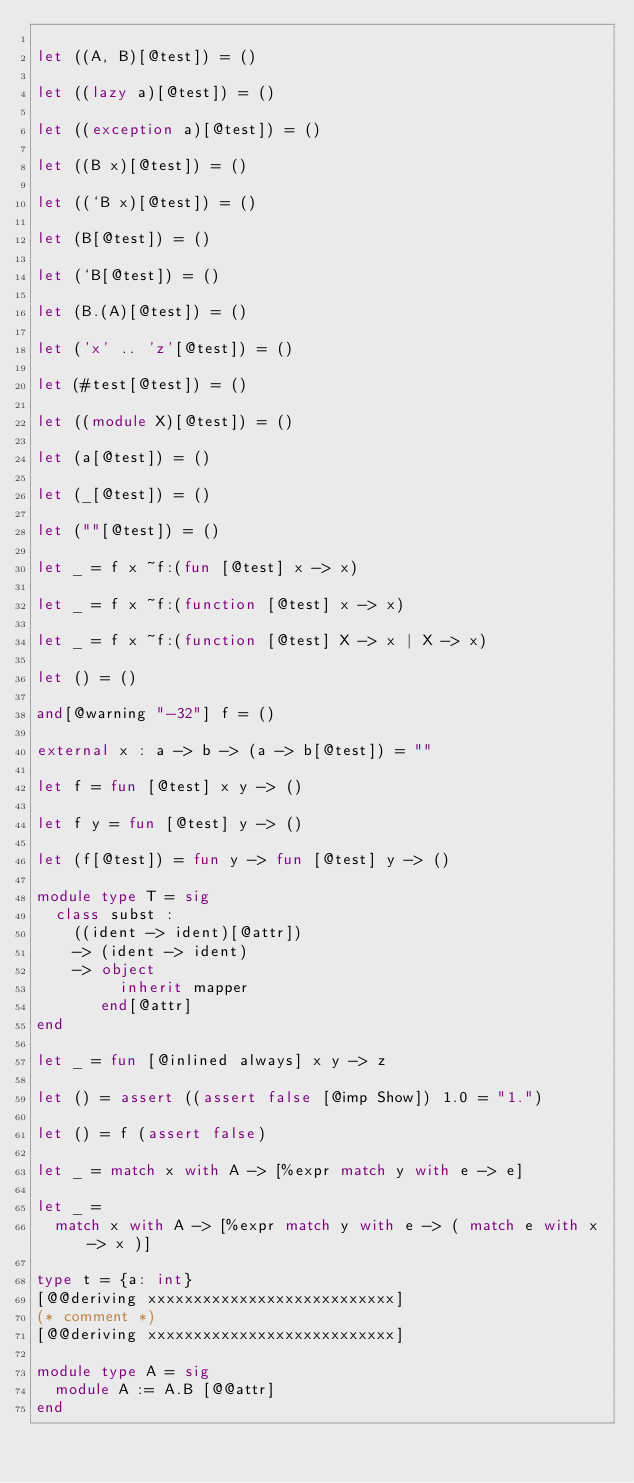Convert code to text. <code><loc_0><loc_0><loc_500><loc_500><_OCaml_>
let ((A, B)[@test]) = ()

let ((lazy a)[@test]) = ()

let ((exception a)[@test]) = ()

let ((B x)[@test]) = ()

let ((`B x)[@test]) = ()

let (B[@test]) = ()

let (`B[@test]) = ()

let (B.(A)[@test]) = ()

let ('x' .. 'z'[@test]) = ()

let (#test[@test]) = ()

let ((module X)[@test]) = ()

let (a[@test]) = ()

let (_[@test]) = ()

let (""[@test]) = ()

let _ = f x ~f:(fun [@test] x -> x)

let _ = f x ~f:(function [@test] x -> x)

let _ = f x ~f:(function [@test] X -> x | X -> x)

let () = ()

and[@warning "-32"] f = ()

external x : a -> b -> (a -> b[@test]) = ""

let f = fun [@test] x y -> ()

let f y = fun [@test] y -> ()

let (f[@test]) = fun y -> fun [@test] y -> ()

module type T = sig
  class subst :
    ((ident -> ident)[@attr])
    -> (ident -> ident)
    -> object
         inherit mapper
       end[@attr]
end

let _ = fun [@inlined always] x y -> z

let () = assert ((assert false [@imp Show]) 1.0 = "1.")

let () = f (assert false)

let _ = match x with A -> [%expr match y with e -> e]

let _ =
  match x with A -> [%expr match y with e -> ( match e with x -> x )]

type t = {a: int}
[@@deriving xxxxxxxxxxxxxxxxxxxxxxxxxxx]
(* comment *)
[@@deriving xxxxxxxxxxxxxxxxxxxxxxxxxxx]

module type A = sig
  module A := A.B [@@attr]
end
</code> 